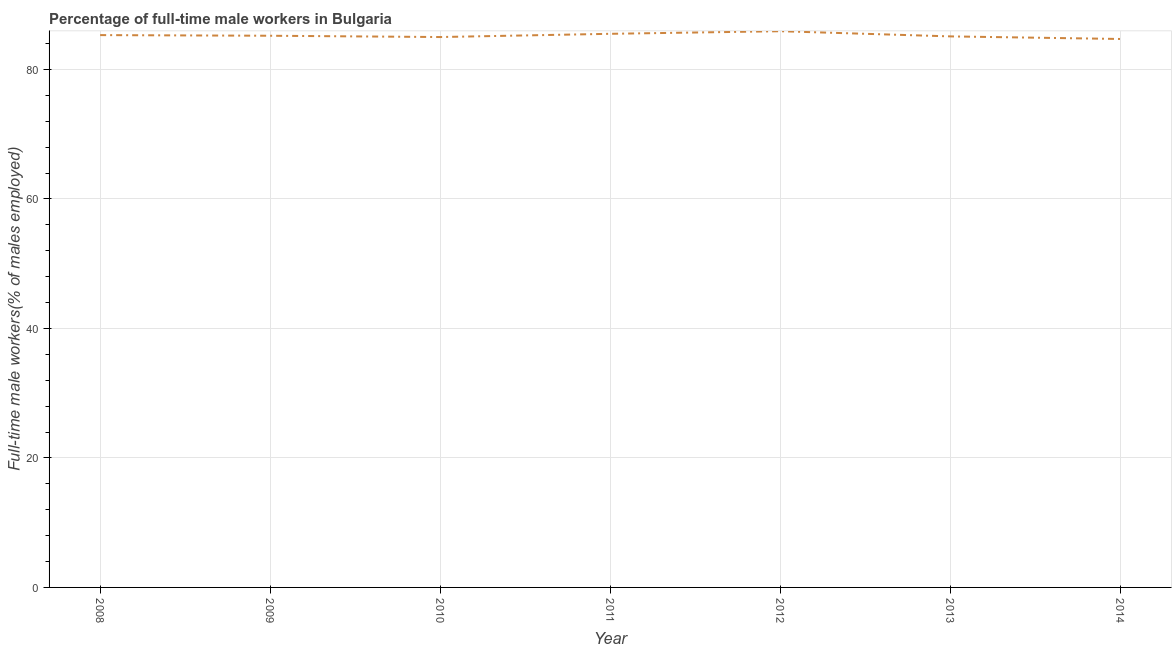What is the percentage of full-time male workers in 2009?
Give a very brief answer. 85.2. Across all years, what is the maximum percentage of full-time male workers?
Make the answer very short. 85.9. Across all years, what is the minimum percentage of full-time male workers?
Provide a short and direct response. 84.7. In which year was the percentage of full-time male workers minimum?
Give a very brief answer. 2014. What is the sum of the percentage of full-time male workers?
Your response must be concise. 596.7. What is the difference between the percentage of full-time male workers in 2010 and 2012?
Your answer should be compact. -0.9. What is the average percentage of full-time male workers per year?
Offer a terse response. 85.24. What is the median percentage of full-time male workers?
Keep it short and to the point. 85.2. What is the ratio of the percentage of full-time male workers in 2008 to that in 2014?
Make the answer very short. 1.01. Is the difference between the percentage of full-time male workers in 2010 and 2011 greater than the difference between any two years?
Your answer should be very brief. No. What is the difference between the highest and the second highest percentage of full-time male workers?
Ensure brevity in your answer.  0.4. Is the sum of the percentage of full-time male workers in 2008 and 2009 greater than the maximum percentage of full-time male workers across all years?
Offer a terse response. Yes. What is the difference between the highest and the lowest percentage of full-time male workers?
Your answer should be very brief. 1.2. In how many years, is the percentage of full-time male workers greater than the average percentage of full-time male workers taken over all years?
Your answer should be very brief. 3. Does the percentage of full-time male workers monotonically increase over the years?
Offer a terse response. No. How many years are there in the graph?
Ensure brevity in your answer.  7. What is the difference between two consecutive major ticks on the Y-axis?
Offer a very short reply. 20. Are the values on the major ticks of Y-axis written in scientific E-notation?
Your answer should be very brief. No. Does the graph contain any zero values?
Offer a very short reply. No. What is the title of the graph?
Your response must be concise. Percentage of full-time male workers in Bulgaria. What is the label or title of the X-axis?
Offer a very short reply. Year. What is the label or title of the Y-axis?
Your answer should be very brief. Full-time male workers(% of males employed). What is the Full-time male workers(% of males employed) of 2008?
Make the answer very short. 85.3. What is the Full-time male workers(% of males employed) in 2009?
Offer a very short reply. 85.2. What is the Full-time male workers(% of males employed) of 2010?
Make the answer very short. 85. What is the Full-time male workers(% of males employed) of 2011?
Ensure brevity in your answer.  85.5. What is the Full-time male workers(% of males employed) of 2012?
Offer a terse response. 85.9. What is the Full-time male workers(% of males employed) in 2013?
Your response must be concise. 85.1. What is the Full-time male workers(% of males employed) in 2014?
Your answer should be compact. 84.7. What is the difference between the Full-time male workers(% of males employed) in 2008 and 2009?
Make the answer very short. 0.1. What is the difference between the Full-time male workers(% of males employed) in 2008 and 2010?
Your response must be concise. 0.3. What is the difference between the Full-time male workers(% of males employed) in 2008 and 2012?
Provide a short and direct response. -0.6. What is the difference between the Full-time male workers(% of males employed) in 2008 and 2013?
Offer a very short reply. 0.2. What is the difference between the Full-time male workers(% of males employed) in 2008 and 2014?
Your answer should be very brief. 0.6. What is the difference between the Full-time male workers(% of males employed) in 2009 and 2013?
Make the answer very short. 0.1. What is the difference between the Full-time male workers(% of males employed) in 2011 and 2012?
Provide a succinct answer. -0.4. What is the difference between the Full-time male workers(% of males employed) in 2011 and 2014?
Offer a terse response. 0.8. What is the difference between the Full-time male workers(% of males employed) in 2012 and 2013?
Provide a short and direct response. 0.8. What is the difference between the Full-time male workers(% of males employed) in 2012 and 2014?
Your answer should be compact. 1.2. What is the ratio of the Full-time male workers(% of males employed) in 2008 to that in 2011?
Give a very brief answer. 1. What is the ratio of the Full-time male workers(% of males employed) in 2008 to that in 2012?
Your answer should be compact. 0.99. What is the ratio of the Full-time male workers(% of males employed) in 2008 to that in 2014?
Keep it short and to the point. 1.01. What is the ratio of the Full-time male workers(% of males employed) in 2009 to that in 2010?
Ensure brevity in your answer.  1. What is the ratio of the Full-time male workers(% of males employed) in 2010 to that in 2012?
Keep it short and to the point. 0.99. What is the ratio of the Full-time male workers(% of males employed) in 2010 to that in 2013?
Your response must be concise. 1. What is the ratio of the Full-time male workers(% of males employed) in 2011 to that in 2012?
Offer a terse response. 0.99. What is the ratio of the Full-time male workers(% of males employed) in 2011 to that in 2013?
Your response must be concise. 1. What is the ratio of the Full-time male workers(% of males employed) in 2011 to that in 2014?
Provide a short and direct response. 1.01. 